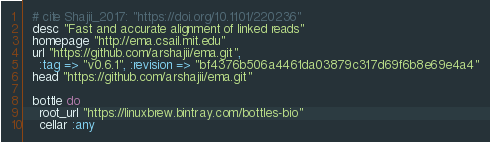Convert code to text. <code><loc_0><loc_0><loc_500><loc_500><_Ruby_>  # cite Shajii_2017: "https://doi.org/10.1101/220236"
  desc "Fast and accurate alignment of linked reads"
  homepage "http://ema.csail.mit.edu"
  url "https://github.com/arshajii/ema.git",
    :tag => "v0.6.1", :revision => "bf4376b506a4461da03879c317d69f6b8e69e4a4"
  head "https://github.com/arshajii/ema.git"

  bottle do
    root_url "https://linuxbrew.bintray.com/bottles-bio"
    cellar :any</code> 